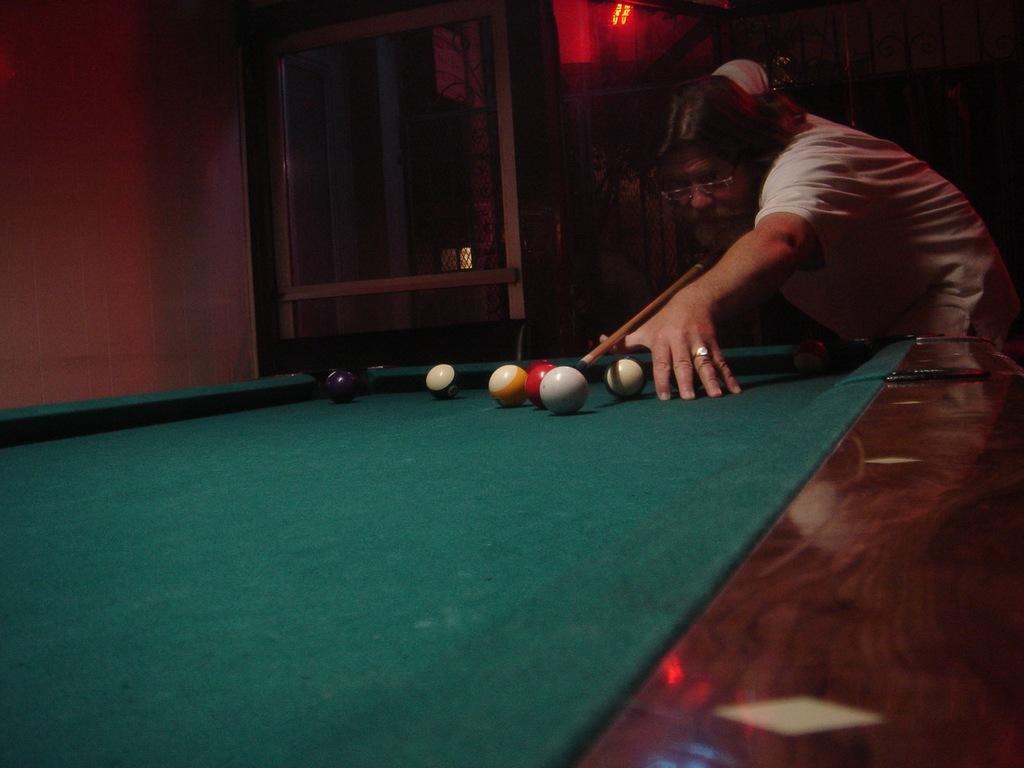Can you describe this image briefly? In the image their man playing snooker on a snooker board ,the room is total dark and there is a red light in the middle of the room. 